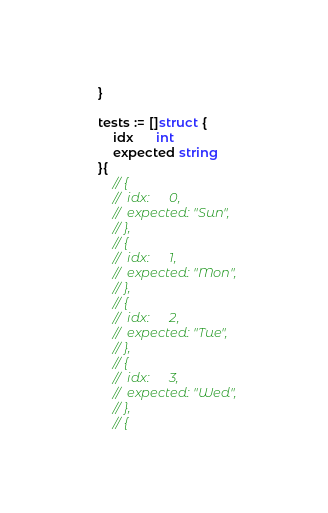Convert code to text. <code><loc_0><loc_0><loc_500><loc_500><_Go_>	}

	tests := []struct {
		idx      int
		expected string
	}{
		// {
		// 	idx:      0,
		// 	expected: "Sun",
		// },
		// {
		// 	idx:      1,
		// 	expected: "Mon",
		// },
		// {
		// 	idx:      2,
		// 	expected: "Tue",
		// },
		// {
		// 	idx:      3,
		// 	expected: "Wed",
		// },
		// {</code> 